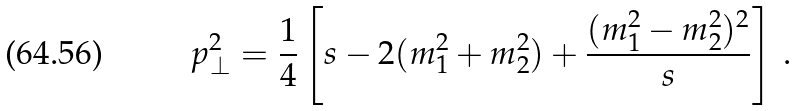<formula> <loc_0><loc_0><loc_500><loc_500>p _ { \perp } ^ { 2 } = \frac { 1 } { 4 } \left [ s - 2 ( m _ { 1 } ^ { 2 } + m _ { 2 } ^ { 2 } ) + \frac { ( m _ { 1 } ^ { 2 } - m _ { 2 } ^ { 2 } ) ^ { 2 } } { s } \right ] \, .</formula> 